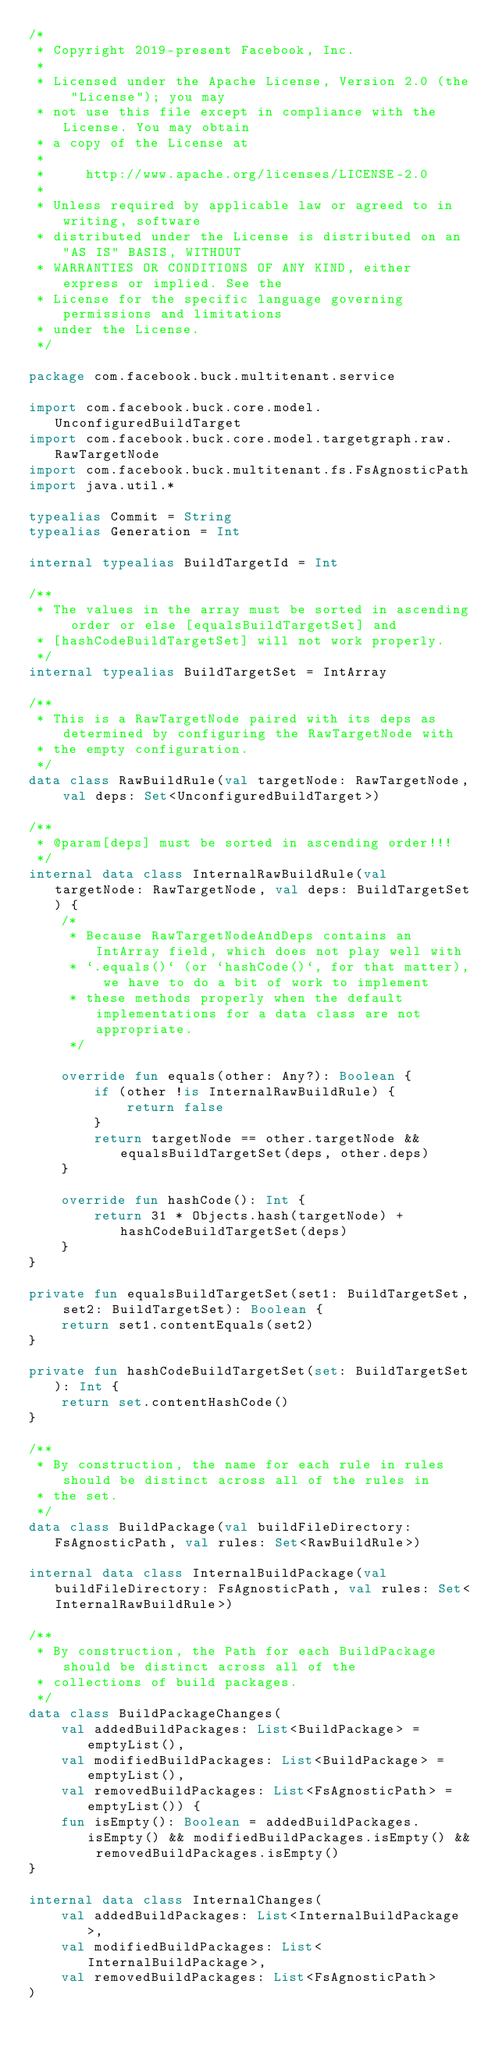<code> <loc_0><loc_0><loc_500><loc_500><_Kotlin_>/*
 * Copyright 2019-present Facebook, Inc.
 *
 * Licensed under the Apache License, Version 2.0 (the "License"); you may
 * not use this file except in compliance with the License. You may obtain
 * a copy of the License at
 *
 *     http://www.apache.org/licenses/LICENSE-2.0
 *
 * Unless required by applicable law or agreed to in writing, software
 * distributed under the License is distributed on an "AS IS" BASIS, WITHOUT
 * WARRANTIES OR CONDITIONS OF ANY KIND, either express or implied. See the
 * License for the specific language governing permissions and limitations
 * under the License.
 */

package com.facebook.buck.multitenant.service

import com.facebook.buck.core.model.UnconfiguredBuildTarget
import com.facebook.buck.core.model.targetgraph.raw.RawTargetNode
import com.facebook.buck.multitenant.fs.FsAgnosticPath
import java.util.*

typealias Commit = String
typealias Generation = Int

internal typealias BuildTargetId = Int

/**
 * The values in the array must be sorted in ascending order or else [equalsBuildTargetSet] and
 * [hashCodeBuildTargetSet] will not work properly.
 */
internal typealias BuildTargetSet = IntArray

/**
 * This is a RawTargetNode paired with its deps as determined by configuring the RawTargetNode with
 * the empty configuration.
 */
data class RawBuildRule(val targetNode: RawTargetNode, val deps: Set<UnconfiguredBuildTarget>)

/**
 * @param[deps] must be sorted in ascending order!!!
 */
internal data class InternalRawBuildRule(val targetNode: RawTargetNode, val deps: BuildTargetSet) {
    /*
     * Because RawTargetNodeAndDeps contains an IntArray field, which does not play well with
     * `.equals()` (or `hashCode()`, for that matter), we have to do a bit of work to implement
     * these methods properly when the default implementations for a data class are not appropriate.
     */

    override fun equals(other: Any?): Boolean {
        if (other !is InternalRawBuildRule) {
            return false
        }
        return targetNode == other.targetNode && equalsBuildTargetSet(deps, other.deps)
    }

    override fun hashCode(): Int {
        return 31 * Objects.hash(targetNode) + hashCodeBuildTargetSet(deps)
    }
}

private fun equalsBuildTargetSet(set1: BuildTargetSet, set2: BuildTargetSet): Boolean {
    return set1.contentEquals(set2)
}

private fun hashCodeBuildTargetSet(set: BuildTargetSet): Int {
    return set.contentHashCode()
}

/**
 * By construction, the name for each rule in rules should be distinct across all of the rules in
 * the set.
 */
data class BuildPackage(val buildFileDirectory: FsAgnosticPath, val rules: Set<RawBuildRule>)

internal data class InternalBuildPackage(val buildFileDirectory: FsAgnosticPath, val rules: Set<InternalRawBuildRule>)

/**
 * By construction, the Path for each BuildPackage should be distinct across all of the
 * collections of build packages.
 */
data class BuildPackageChanges(
    val addedBuildPackages: List<BuildPackage> = emptyList(),
    val modifiedBuildPackages: List<BuildPackage> = emptyList(),
    val removedBuildPackages: List<FsAgnosticPath> = emptyList()) {
    fun isEmpty(): Boolean = addedBuildPackages.isEmpty() && modifiedBuildPackages.isEmpty() && removedBuildPackages.isEmpty()
}

internal data class InternalChanges(
    val addedBuildPackages: List<InternalBuildPackage>,
    val modifiedBuildPackages: List<InternalBuildPackage>,
    val removedBuildPackages: List<FsAgnosticPath>
)
</code> 